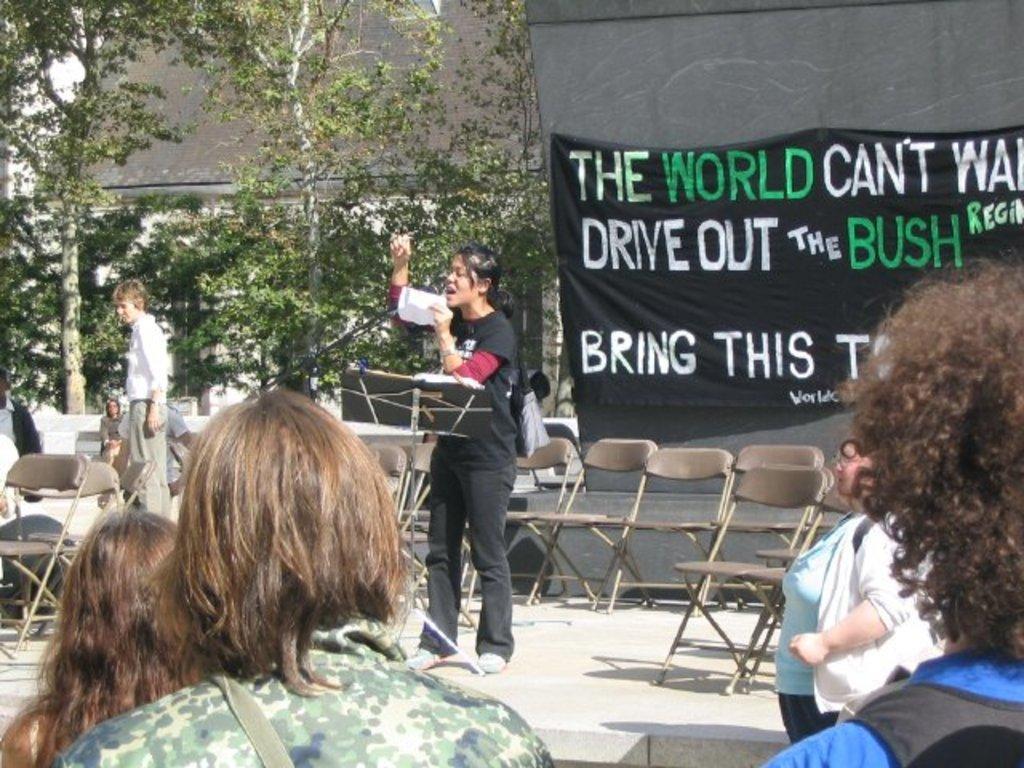Describe this image in one or two sentences. In this image there are people, chairs, banner, trees, wall and objects. Among them one person is holding a paper. Something is written on the banner. 